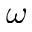<formula> <loc_0><loc_0><loc_500><loc_500>\omega</formula> 